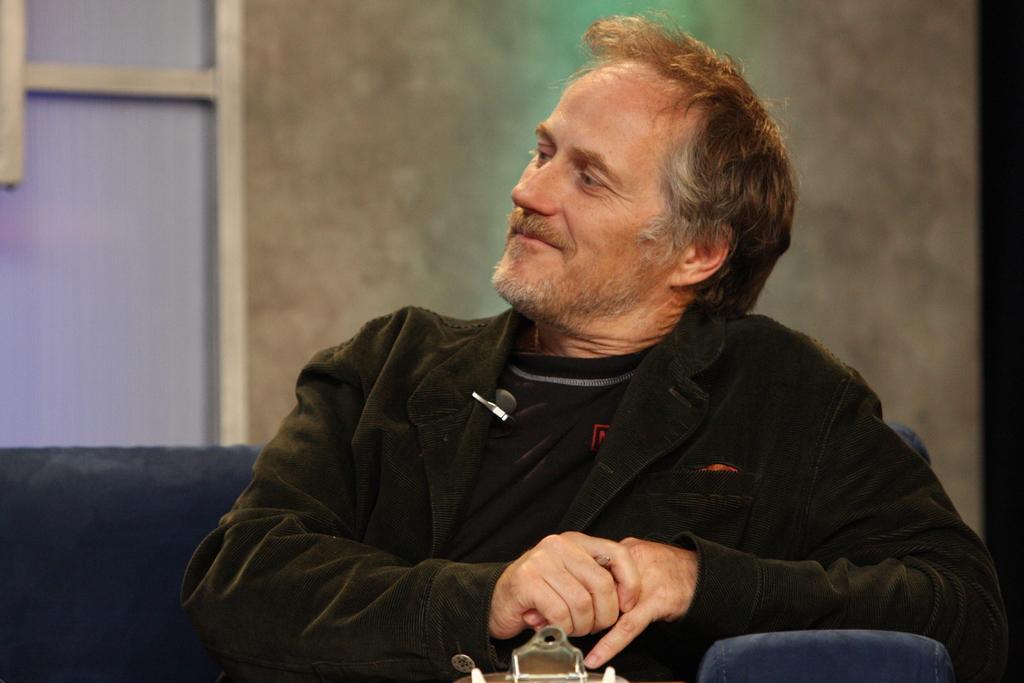In one or two sentences, can you explain what this image depicts? In the center of the image we can see a person is sitting on the couch. And we can see he is smiling and he is in a different costume. At the bottom of the image, we can see some object. In the background there is a wall and a window. 